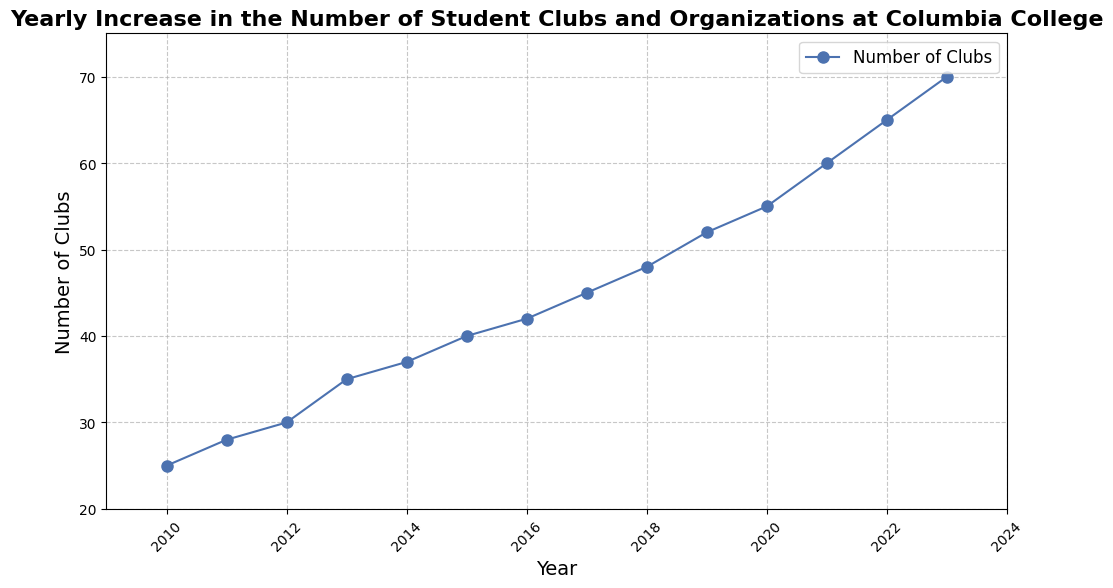What is the total increase in the number of student clubs from 2010 to 2023? To find the total increase, subtract the number of clubs in 2010 from the number of clubs in 2023. This gives 70 (2023) - 25 (2010) = 45.
Answer: 45 By how many clubs did the number grow between 2018 and 2022? First, find the number of clubs in 2018 and 2022. Then, subtract the number of clubs in 2018 from the number in 2022: 65 (2022) - 48 (2018) = 17.
Answer: 17 In which year was the number of student clubs first equal to or exceeded 50? According to the figure, the number of student clubs first exceeded 50 in 2019.
Answer: 2019 What was the average number of clubs per year from 2010 to 2015? First, sum the number of clubs from 2010 to 2015: 25 + 28 + 30 + 35 + 37 + 40 = 195. Then, divide by the number of years (6): 195 / 6 ≈ 32.5.
Answer: 32.5 Compare the growth rate of student clubs between the periods 2010-2013 and 2020-2023. Which period saw a higher growth rate? Calculate the yearly growth rates for each period. For 2010-2013: (35 - 25) / (2013 - 2010) = 10 / 3 ≈ 3.33. For 2020-2023: (70 - 55) / (2023 - 2020) = 15 / 3 = 5. The period 2020-2023 saw a higher growth rate.
Answer: 2020-2023 What is the median number of clubs from 2010 to 2023? List the number of clubs in ascending order: 25, 28, 30, 35, 37, 40, 42, 45, 48, 52, 55, 60, 65, 70. Since there are an even number of data points (14), the median is the average of the 7th and 8th values: (42 + 45) / 2 = 43.5.
Answer: 43.5 Which year experienced the largest single-year increase in the number of clubs? By visually inspecting the chart, identify the steepest slope. The largest single-year increase occurred between 2020 and 2021, with an increase of 5 clubs.
Answer: 2020-2021 What is the trend in the number of clubs from 2010 to 2023? By observing the plotted line, the trend shows a consistent and steady increase in the number of student clubs over the years from 2010 to 2023.
Answer: Steady increase How does the increase from 2011 to 2012 compare to the increase from 2017 to 2018? The increase from 2011 to 2012 is 30 - 28 = 2 clubs. The increase from 2017 to 2018 is 48 - 45 = 3 clubs. The increase from 2017 to 2018 is greater.
Answer: 2017-2018 What is the color used to represent the number of clubs in this chart? The color used to represent the number of clubs on the line is blue.
Answer: Blue 